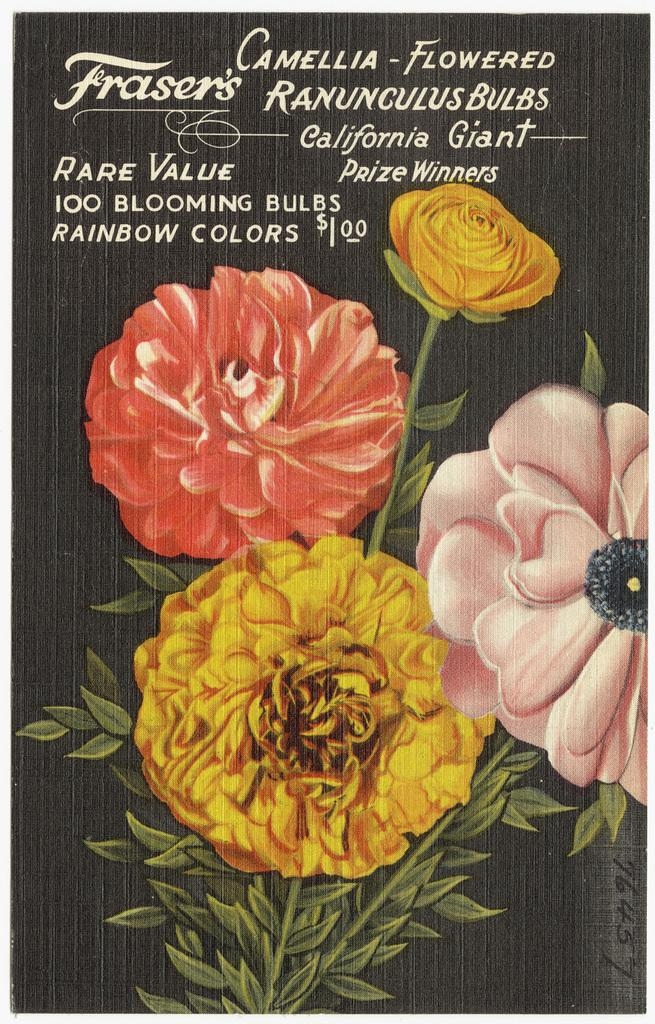What colors are the flowers in the image? The flowers in the image are in yellow, pink, and orange colors. What color are the leaves in the image? The leaves in the image are green. What can be seen written on the image? There is something written on the image. What color is the background of the image? The background of the image is black. Can you see a tree running in the image? There is no tree or running depicted in the image. 